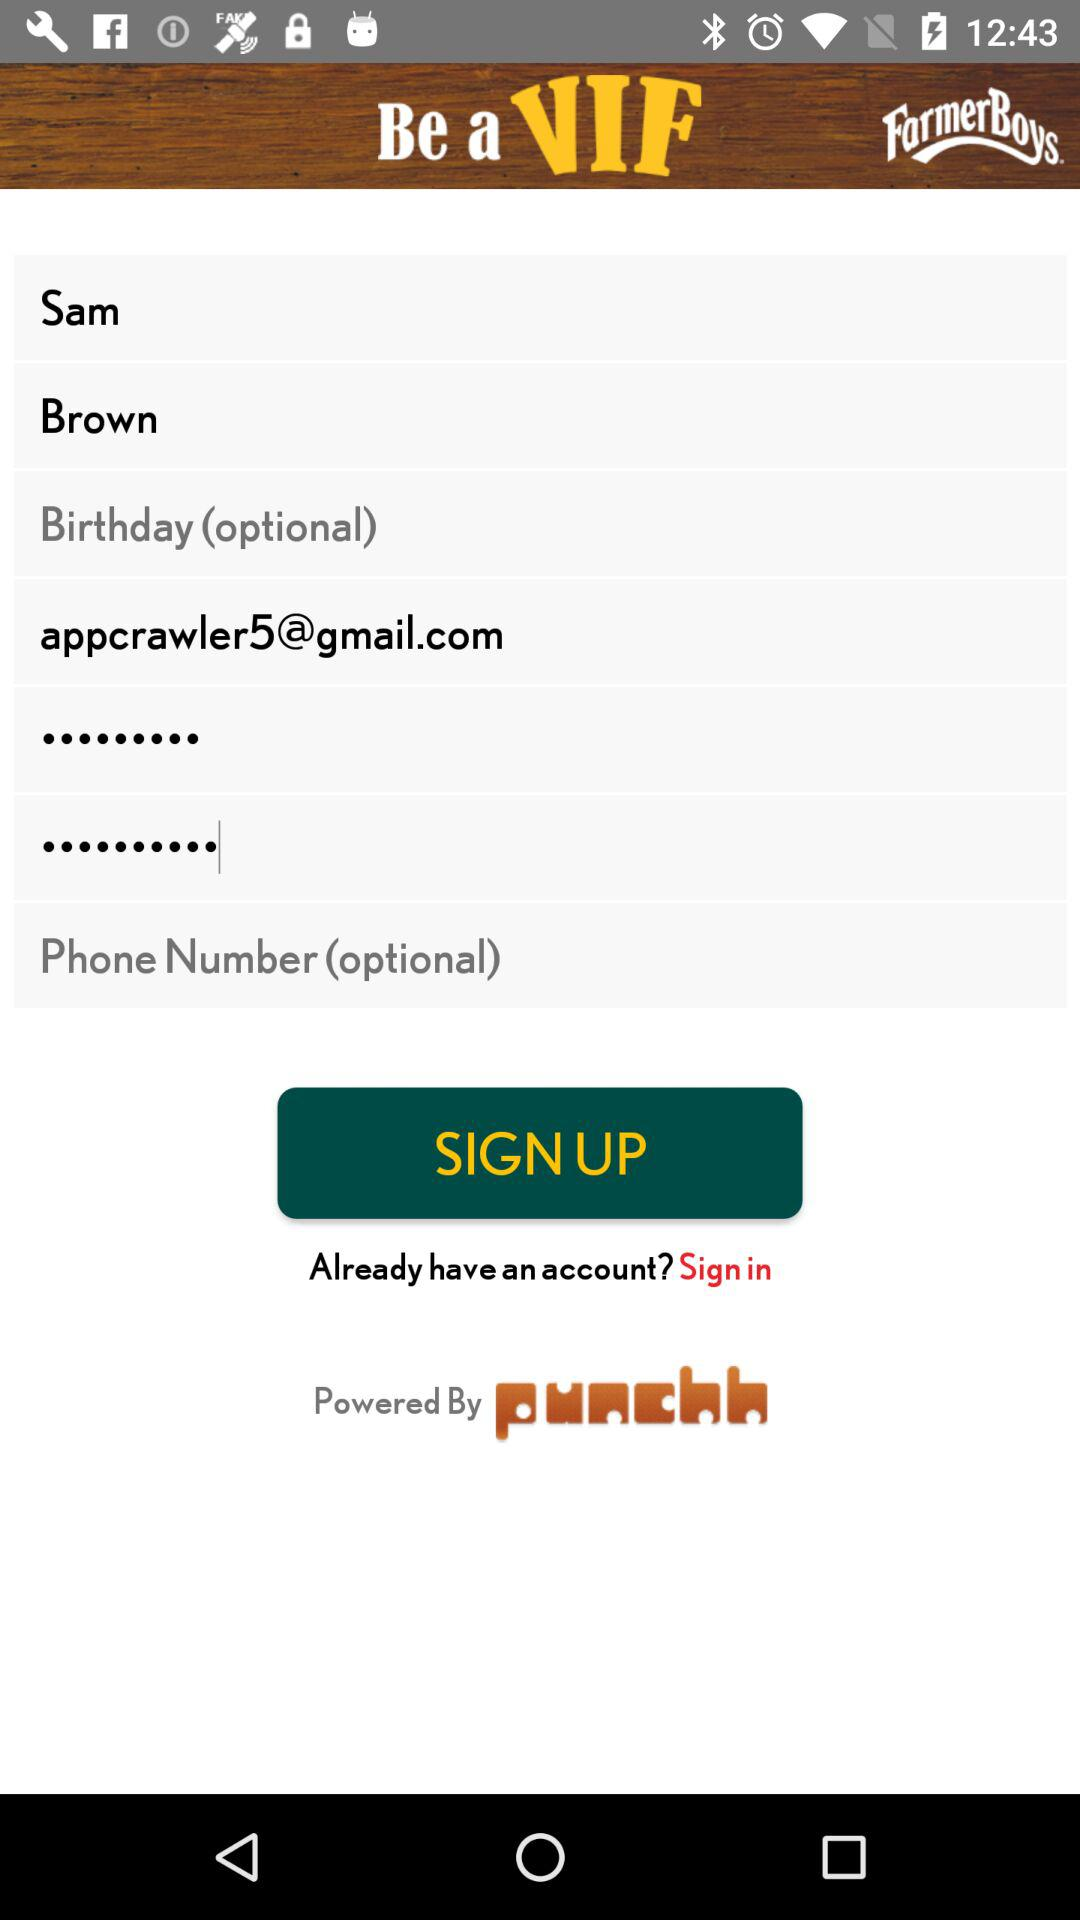What is the name of the application? The application name is "Be a VIF". 